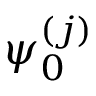Convert formula to latex. <formula><loc_0><loc_0><loc_500><loc_500>\psi _ { 0 } ^ { ( j ) }</formula> 